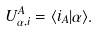Convert formula to latex. <formula><loc_0><loc_0><loc_500><loc_500>U ^ { A } _ { \alpha , i } = \langle i _ { A } | \alpha \rangle .</formula> 